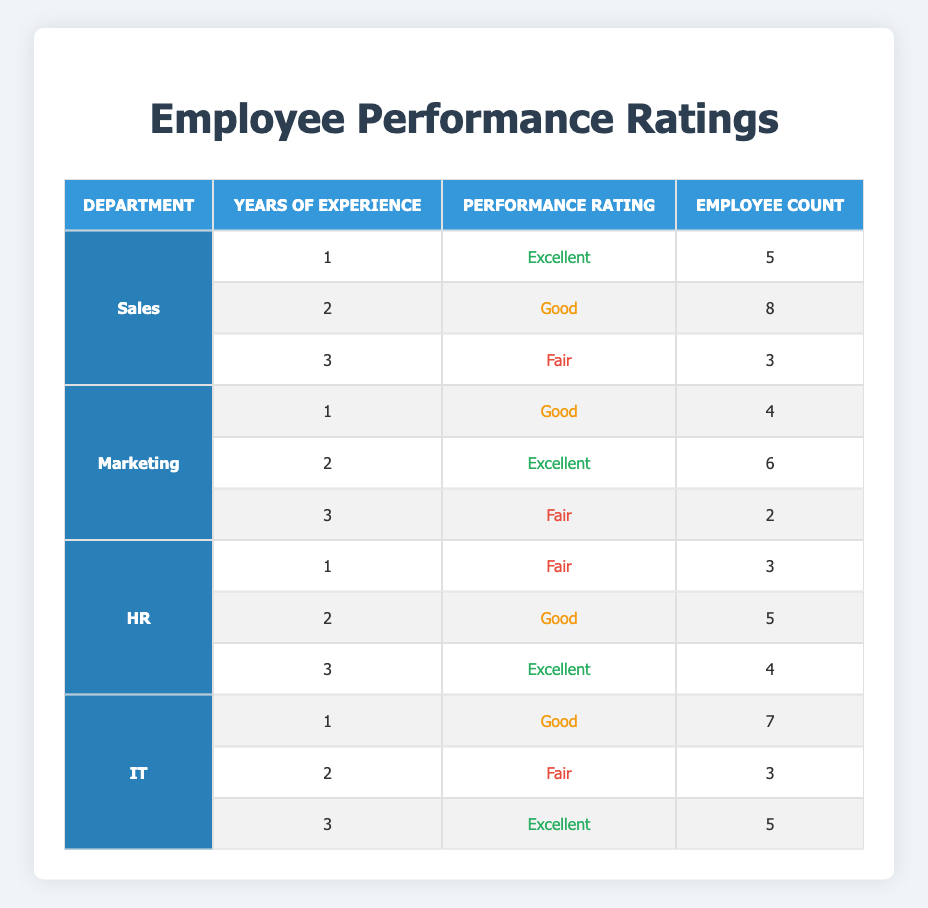What is the performance rating for employees with 2 years of experience in the Sales department? According to the table, the Sales department has 8 employees with 2 years of experience, and their performance rating is classified as "Good."
Answer: Good How many employees in total rated their performance as Fair across all departments? By examining the table, there are 3 employees in Sales, 2 in Marketing, 3 in HR, and 3 in IT, with a Fair rating. Summing these gives us 3 + 2 + 3 + 3 = 11.
Answer: 11 Which department has the highest number of Excellent ratings and how many are there? Looking at the table, the departments with Excellent ratings are: Sales (1), Marketing (2), HR (3), and IT (3). The departments with the most Excellent ratings are HR and IT, each with 3 ratings.
Answer: HR and IT, 3 Is it true that HR has more Good ratings than Marketing? In the HR department, there are 5 Good ratings, while in Marketing there are only 6. Therefore, it's false that HR has more Good ratings than Marketing.
Answer: No What is the average number of employees rated Excellent across all departments? In the table, the total count of Excellent ratings is from HR (4), Marketing (6), Sales (5), and IT (5). Summing those gives 4 + 6 + 5 + 5 = 20. Since there are 4 data points (departments), the average is 20 / 4 = 5.
Answer: 5 How many employees rated Good in the IT department specifically? For the IT department, the table shows that there are 7 employees rated Good for 1 year of experience, and none mentioned at 2 years. Thus, there are a total of 7 employees rated Good in IT.
Answer: 7 In which department do employees with 3 years of experience have the lowest performance rating, and what is that rating? By checking the table, the departments with 3 years of experience show: Sales (Fair), Marketing (Fair), HR (Excellent), and IT (Excellent). The lowest rating is Fair from both Sales and Marketing.
Answer: Sales and Marketing, Fair What is the total number of employees across all departments with less than 3 years of experience rated Excellent? According to the data, only the Sales department has 5 employees rated Excellent at 1 year of experience, and Marketing has 6 employees rated Excellent at 2 years. Thus, 5 + 6 = 11 employees rated Excellent with less than 3 years.
Answer: 11 